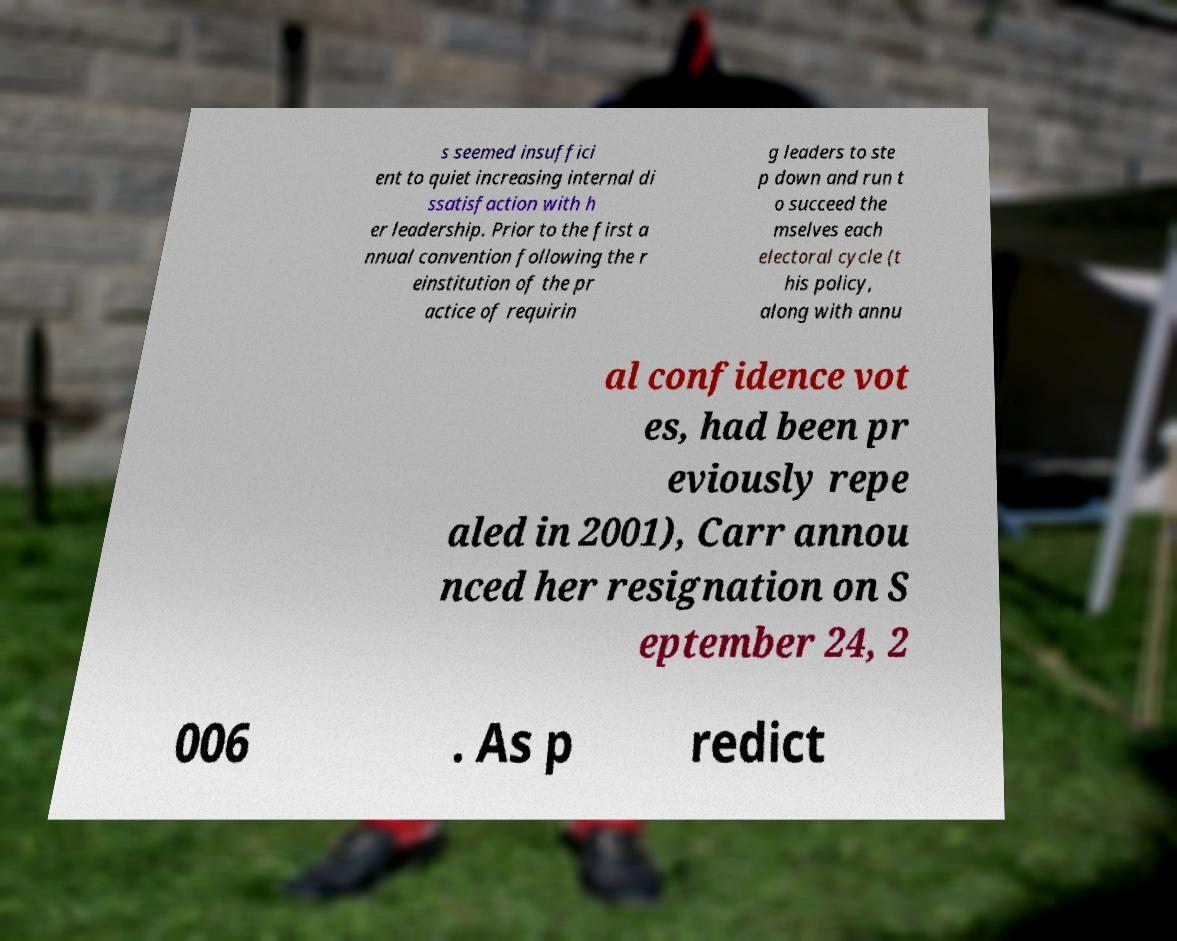Could you extract and type out the text from this image? s seemed insuffici ent to quiet increasing internal di ssatisfaction with h er leadership. Prior to the first a nnual convention following the r einstitution of the pr actice of requirin g leaders to ste p down and run t o succeed the mselves each electoral cycle (t his policy, along with annu al confidence vot es, had been pr eviously repe aled in 2001), Carr annou nced her resignation on S eptember 24, 2 006 . As p redict 